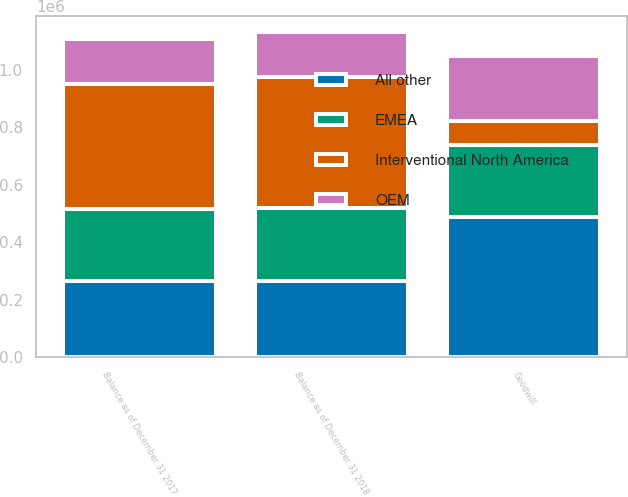Convert chart to OTSL. <chart><loc_0><loc_0><loc_500><loc_500><stacked_bar_chart><ecel><fcel>Goodwill<fcel>Balance as of December 31 2017<fcel>Balance as of December 31 2018<nl><fcel>All other<fcel>485986<fcel>264869<fcel>264869<nl><fcel>Interventional North America<fcel>84615<fcel>433049<fcel>455589<nl><fcel>OEM<fcel>225784<fcel>157289<fcel>156339<nl><fcel>EMEA<fcel>250912<fcel>250912<fcel>253315<nl></chart> 